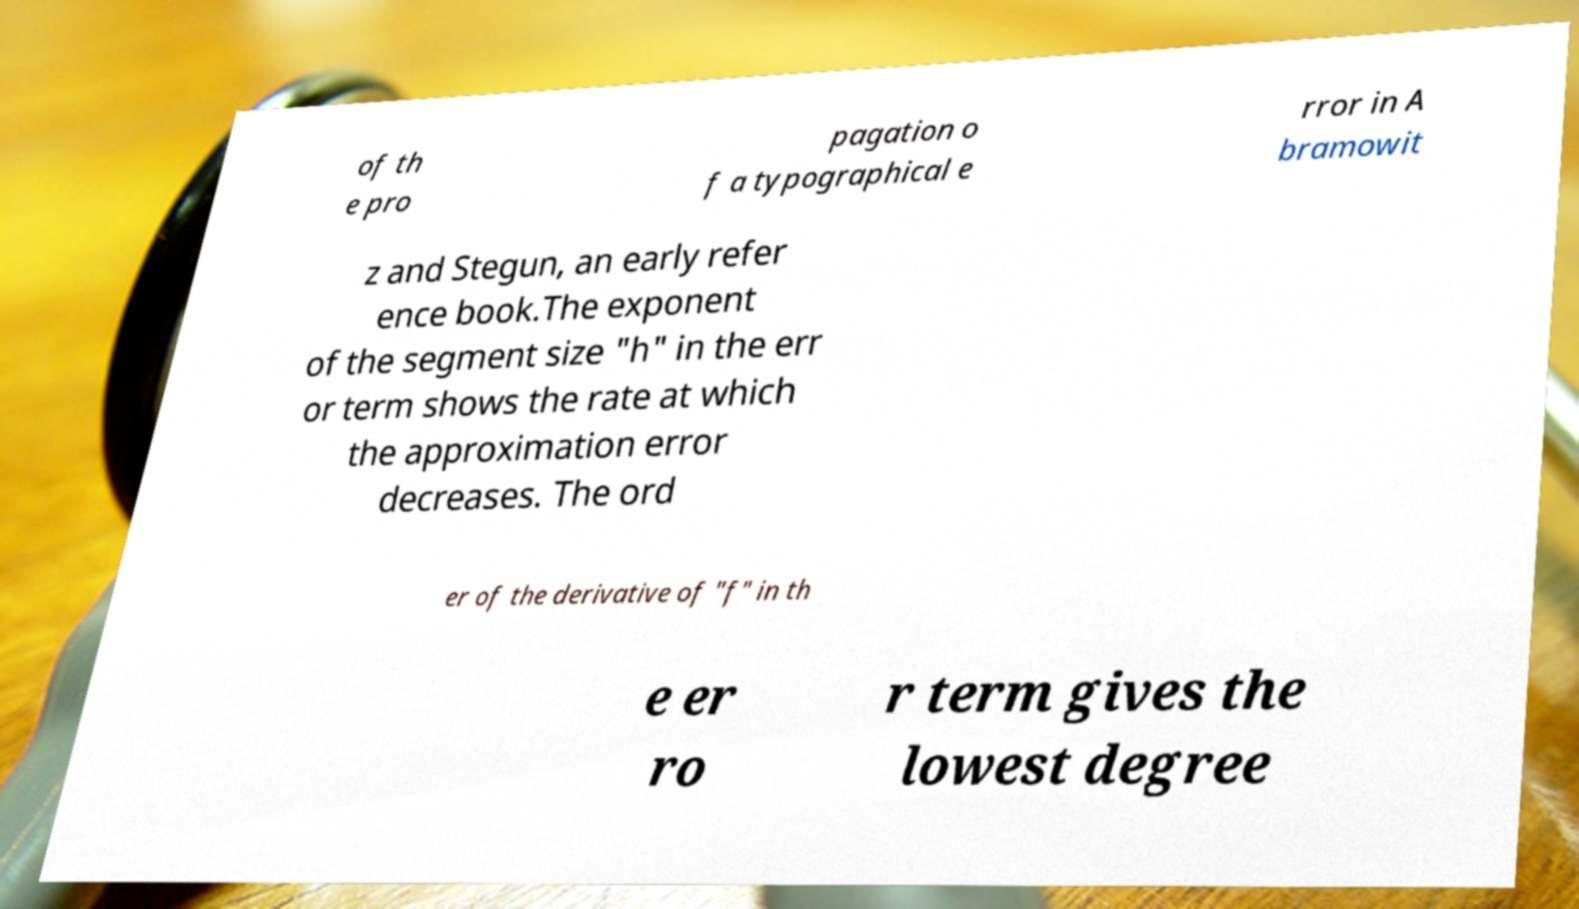Please identify and transcribe the text found in this image. of th e pro pagation o f a typographical e rror in A bramowit z and Stegun, an early refer ence book.The exponent of the segment size "h" in the err or term shows the rate at which the approximation error decreases. The ord er of the derivative of "f" in th e er ro r term gives the lowest degree 